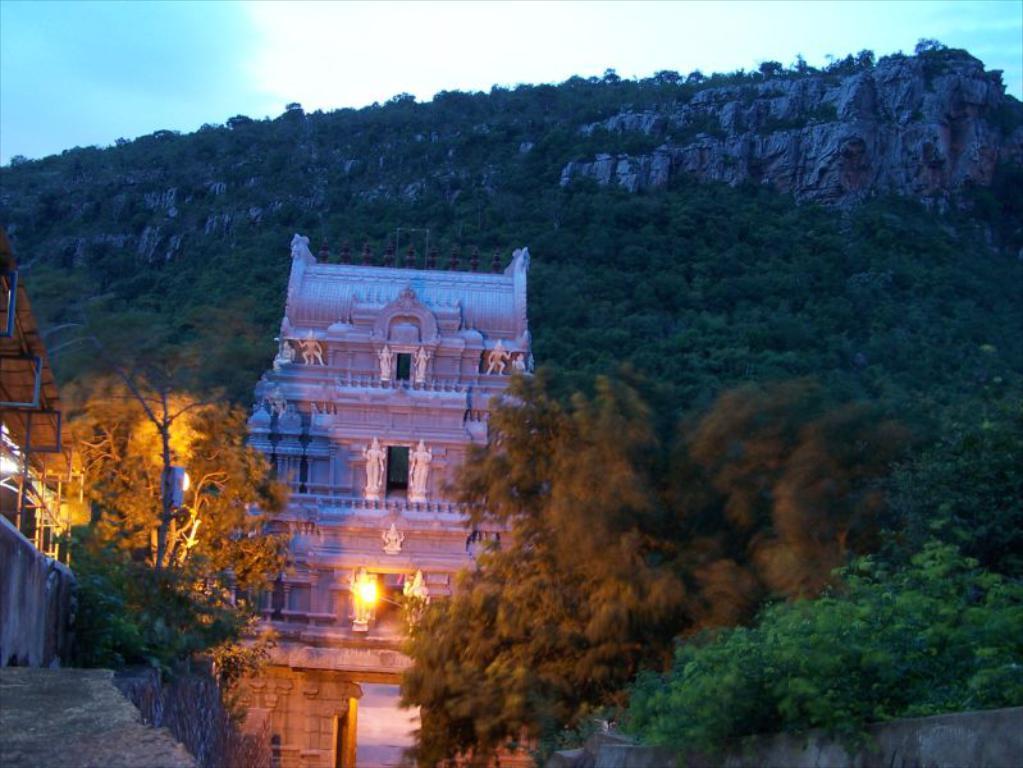In one or two sentences, can you explain what this image depicts? In this image there is a temple. There are sculptures on the wall of the temple. On the either sides of the image there are trees. There are street lights in the image. In the background there are mountains. There are trees on the mountains. At the top there is the sky. 